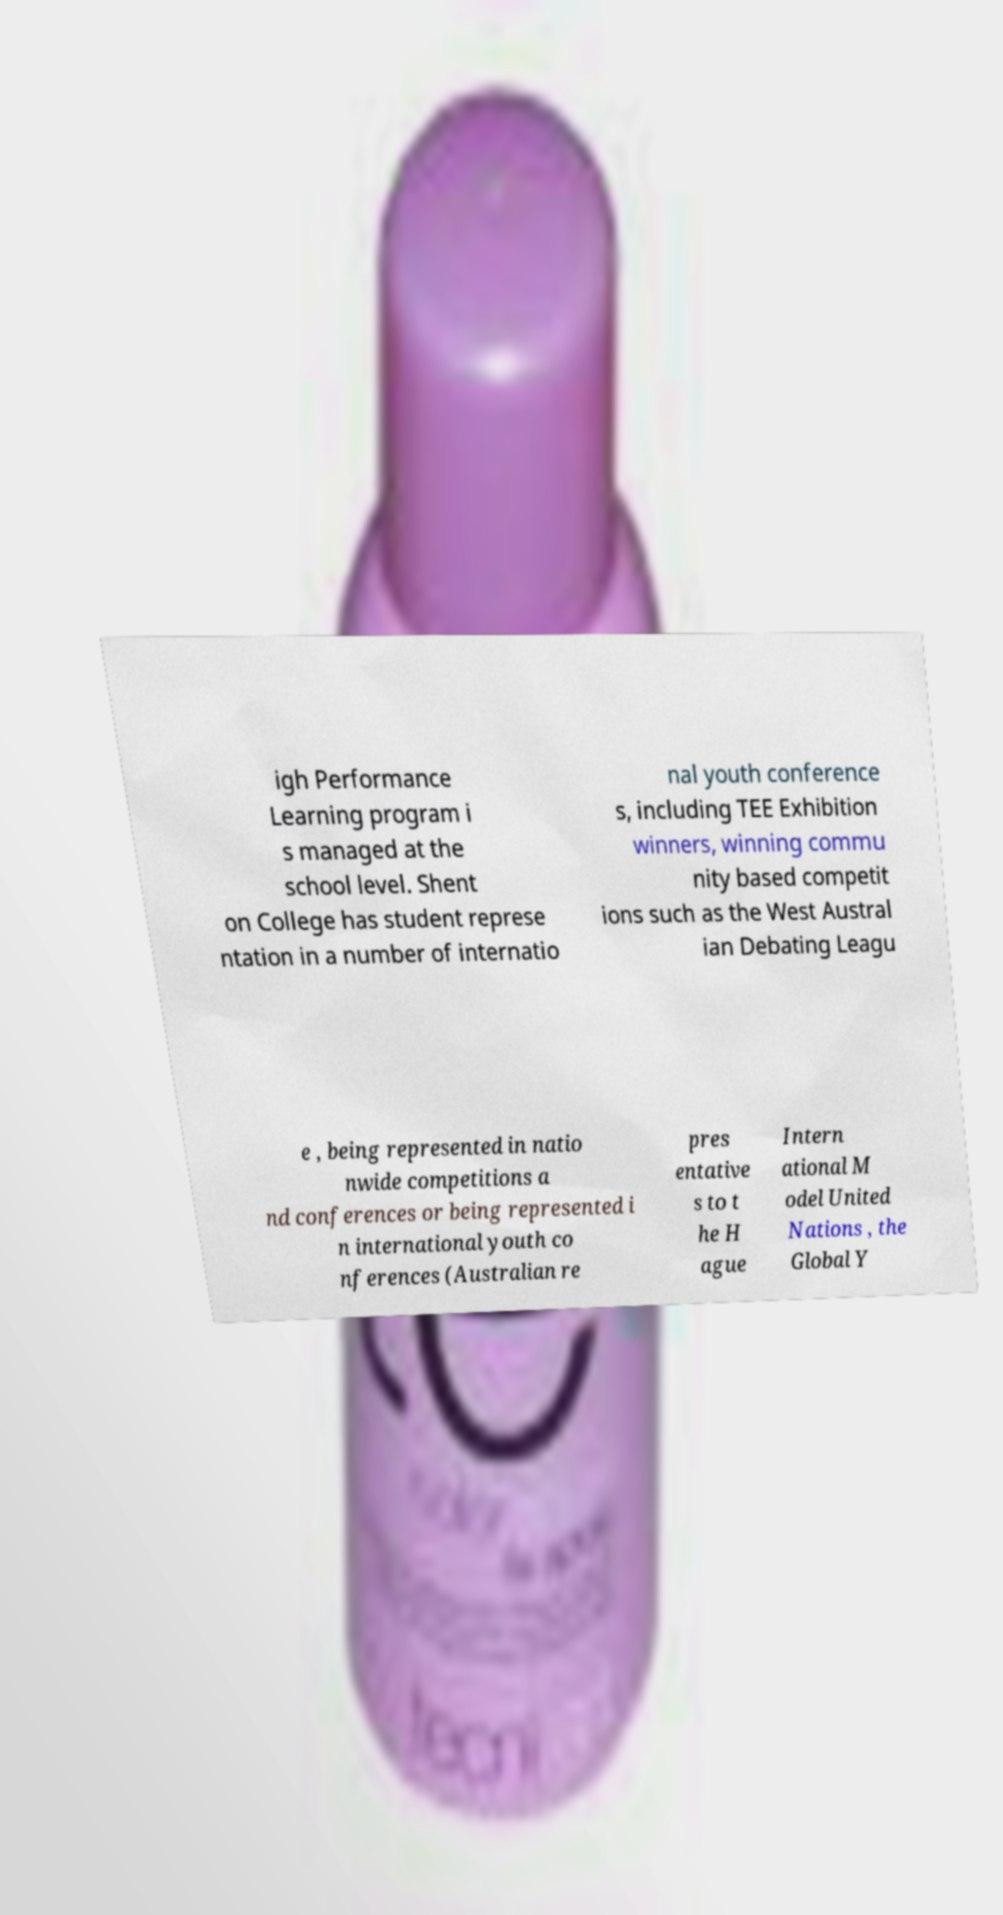For documentation purposes, I need the text within this image transcribed. Could you provide that? igh Performance Learning program i s managed at the school level. Shent on College has student represe ntation in a number of internatio nal youth conference s, including TEE Exhibition winners, winning commu nity based competit ions such as the West Austral ian Debating Leagu e , being represented in natio nwide competitions a nd conferences or being represented i n international youth co nferences (Australian re pres entative s to t he H ague Intern ational M odel United Nations , the Global Y 